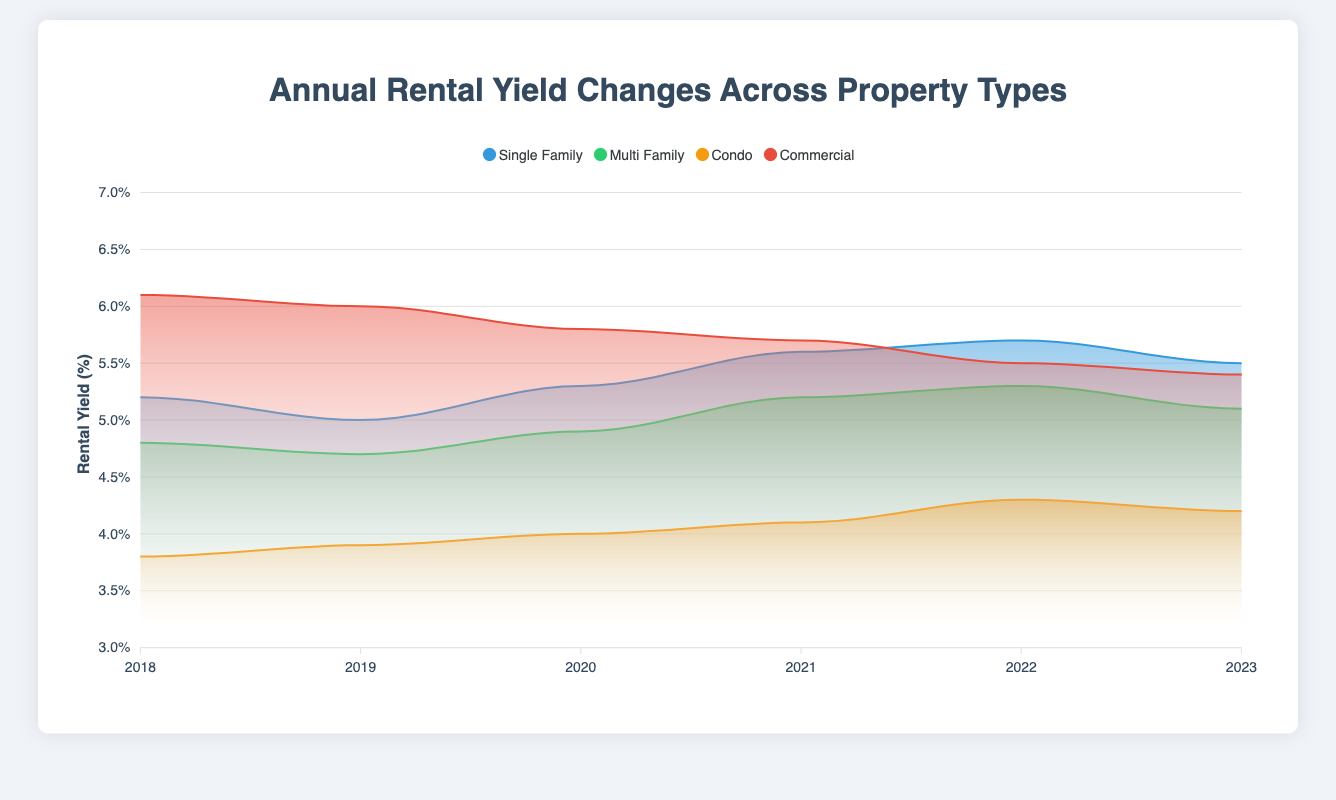What is the highest rental yield for commercial properties across the years? To find this, look for the highest point in the "Commercial" data series on the area chart. The highest rental yield for commercial properties is 6.1% in 2018.
Answer: 6.1% Which year saw the highest rental yield for single-family residences? Analyze the "Single Family" series and identify which year has the peak value. The highest rental yield for single-family residences is 5.7% in 2022.
Answer: 2022 What trend do you observe for condo rental yields from 2018 to 2023? Look at the "Condo" series to see the trend. The rental yields for condos have increased gradually from 3.8% in 2018 to 4.3% in 2022, with a slight dip to 4.2% in 2023.
Answer: Gradual increase with a slight dip in 2023 How has the rental yield for multi-family properties changed from 2019 to 2021? Extract the data for multi-family properties over the specified years and observe the changes. The rental yield for multi-family properties increased from 4.7% in 2019 to 5.2% in 2021.
Answer: Increased from 4.7% to 5.2% Which property type had the most consistent rental yield across the years? Compare the variance in rental yields for all property types. The "Condo" rental yields vary the least, ranging only from 3.8% to 4.3%.
Answer: Condo What is the average rental yield for single-family residences from 2018 to 2023? Sum up the rental yields for single-family residences across the years and divide by the number of years (6). The sum is 5.2 + 5.0 + 5.3 + 5.6 + 5.7 + 5.5 = 32.3, so the average is 32.3 / 6 = 5.38.
Answer: 5.38% By how much did the rental yield for commercial properties fall from its highest point to its lowest point? Identify the highest (6.1%) and lowest (5.4%) rental yields for commercial properties and find the difference. The fall is 6.1% - 5.4% = 0.7%.
Answer: 0.7% Which year saw the greatest increase in rental yield for multi-family properties compared to the previous year? Compare the year-on-year changes in the "Multi Family" series and find the largest increase. The greatest increase was from 2019 to 2020, rising by 0.2% (4.7% to 4.9%).
Answer: 2020 Do single-family residences or commercial properties have a higher rental yield in 2023? Compare the rental yields for these two property types in 2023. The rental yield for single-family residences is 5.5%, whereas for commercial properties, it is 5.4%.
Answer: Single-family residences Across the years, which property type experienced the largest overall change in rental yield? Determine the range (difference between maximum and minimum values) for each property type. "Single Family" has a range of 0.7% (5.7% - 5.0%), "Multi Family" has 0.6% (5.3% - 4.7%), "Condo" has 0.5% (4.3% - 3.8%), and "Commercial" has 0.7% (6.1% - 5.4%). Both single-family and commercial properties experienced the largest changes (0.7%).
Answer: Single-family and Commercial 